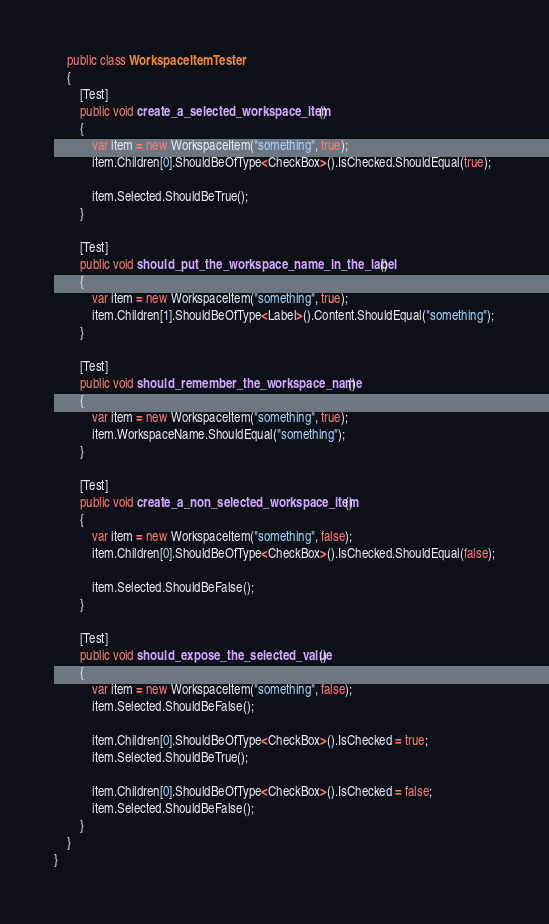Convert code to text. <code><loc_0><loc_0><loc_500><loc_500><_C#_>    public class WorkspaceItemTester
    {
        [Test]
        public void create_a_selected_workspace_item()
        {
            var item = new WorkspaceItem("something", true);
            item.Children[0].ShouldBeOfType<CheckBox>().IsChecked.ShouldEqual(true);
            
            item.Selected.ShouldBeTrue();
        }

        [Test]
        public void should_put_the_workspace_name_in_the_label()
        {
            var item = new WorkspaceItem("something", true);
            item.Children[1].ShouldBeOfType<Label>().Content.ShouldEqual("something");
        }

        [Test]
        public void should_remember_the_workspace_name()
        {
            var item = new WorkspaceItem("something", true);
            item.WorkspaceName.ShouldEqual("something");
        }

        [Test]
        public void create_a_non_selected_workspace_item()
        {
            var item = new WorkspaceItem("something", false);
            item.Children[0].ShouldBeOfType<CheckBox>().IsChecked.ShouldEqual(false);

            item.Selected.ShouldBeFalse();
        }

        [Test]
        public void should_expose_the_selected_value()
        {
            var item = new WorkspaceItem("something", false);
            item.Selected.ShouldBeFalse();

            item.Children[0].ShouldBeOfType<CheckBox>().IsChecked = true;
            item.Selected.ShouldBeTrue();

            item.Children[0].ShouldBeOfType<CheckBox>().IsChecked = false;
            item.Selected.ShouldBeFalse();
        }
    }
}</code> 